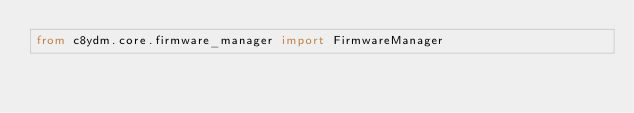<code> <loc_0><loc_0><loc_500><loc_500><_Python_>from c8ydm.core.firmware_manager import FirmwareManager</code> 